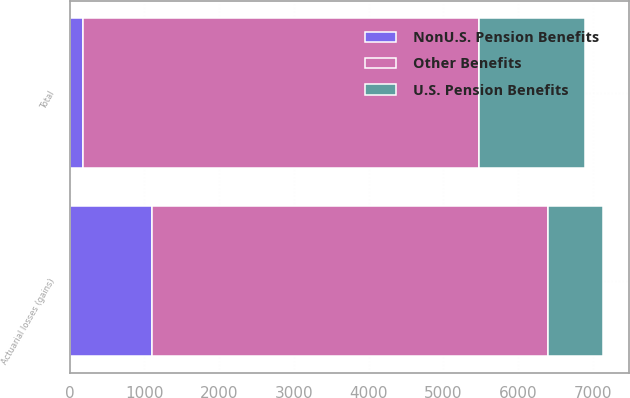<chart> <loc_0><loc_0><loc_500><loc_500><stacked_bar_chart><ecel><fcel>Actuarial losses (gains)<fcel>Total<nl><fcel>Other Benefits<fcel>5297<fcel>5297<nl><fcel>NonU.S. Pension Benefits<fcel>1097<fcel>184<nl><fcel>U.S. Pension Benefits<fcel>736<fcel>1406<nl></chart> 